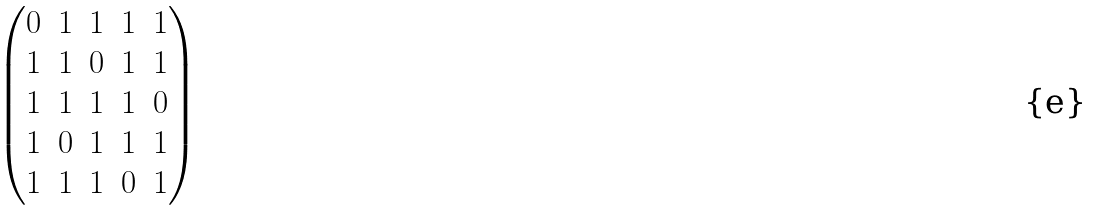<formula> <loc_0><loc_0><loc_500><loc_500>\begin{pmatrix} 0 & 1 & 1 & 1 & 1 \\ 1 & 1 & 0 & 1 & 1 \\ 1 & 1 & 1 & 1 & 0 \\ 1 & 0 & 1 & 1 & 1 \\ 1 & 1 & 1 & 0 & 1 \end{pmatrix}</formula> 